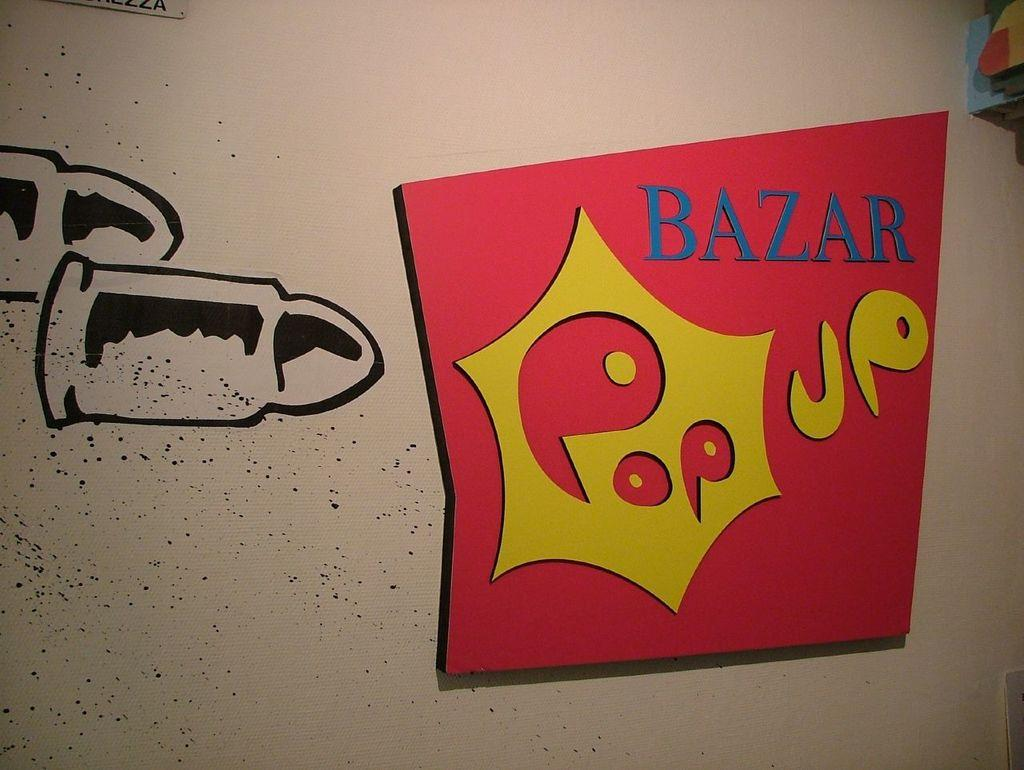Provide a one-sentence caption for the provided image. Words that say Bazar Pop up on a wall next to a drawing of a bullet. 